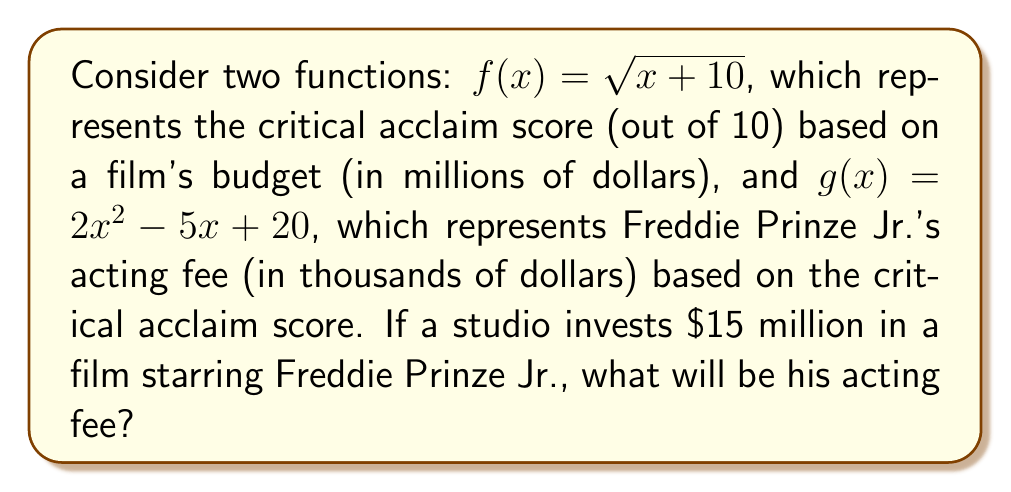Help me with this question. To solve this problem, we need to use function composition. We'll first find the critical acclaim score based on the budget, then use that score to determine Freddie Prinze Jr.'s acting fee.

1. Given budget $x = 15$ million, let's find the critical acclaim score:
   $f(15) = \sqrt{15 + 10} = \sqrt{25} = 5$

2. Now we need to find $g(f(15))$, which is equivalent to $g(5)$:
   $g(5) = 2(5)^2 - 5(5) + 20$

3. Let's calculate this step by step:
   $g(5) = 2(25) - 25 + 20$
   $g(5) = 50 - 25 + 20$
   $g(5) = 45$

4. The result, 45, represents thousands of dollars. So Freddie Prinze Jr.'s acting fee will be $45,000.

This composition of functions, $(g \circ f)(x)$, allows us to directly relate the film's budget to Freddie Prinze Jr.'s acting fee, taking into account the intermediate step of critical acclaim.
Answer: $45,000 